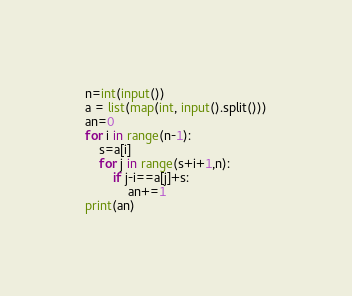<code> <loc_0><loc_0><loc_500><loc_500><_Python_>
n=int(input())
a = list(map(int, input().split()))
an=0
for i in range(n-1):
    s=a[i]
    for j in range(s+i+1,n):
        if j-i==a[j]+s:
            an+=1
print(an)</code> 